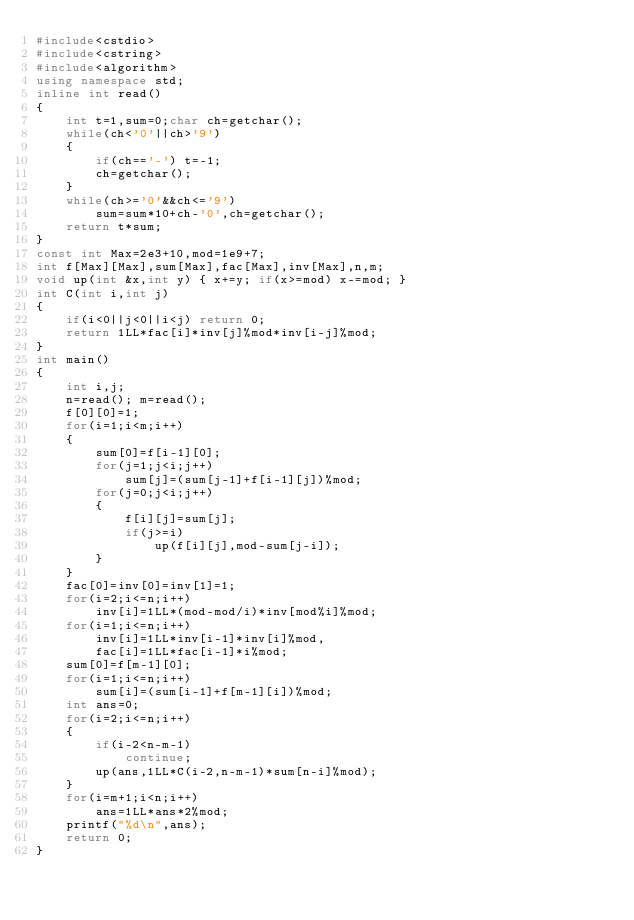<code> <loc_0><loc_0><loc_500><loc_500><_C++_>#include<cstdio>
#include<cstring>
#include<algorithm>
using namespace std;
inline int read()
{
	int t=1,sum=0;char ch=getchar();
	while(ch<'0'||ch>'9')
	{
		if(ch=='-') t=-1;
		ch=getchar();
	}
	while(ch>='0'&&ch<='9')
		sum=sum*10+ch-'0',ch=getchar();
	return t*sum;
}
const int Max=2e3+10,mod=1e9+7;
int f[Max][Max],sum[Max],fac[Max],inv[Max],n,m;
void up(int &x,int y) { x+=y; if(x>=mod) x-=mod; }
int C(int i,int j) 
{ 
	if(i<0||j<0||i<j) return 0;
	return 1LL*fac[i]*inv[j]%mod*inv[i-j]%mod; 
}
int main()
{
	int i,j;
	n=read(); m=read();
	f[0][0]=1;
	for(i=1;i<m;i++)
	{
		sum[0]=f[i-1][0];
		for(j=1;j<i;j++)
			sum[j]=(sum[j-1]+f[i-1][j])%mod;
		for(j=0;j<i;j++)
		{
			f[i][j]=sum[j];
			if(j>=i)
				up(f[i][j],mod-sum[j-i]);
		}
	}
	fac[0]=inv[0]=inv[1]=1;
	for(i=2;i<=n;i++)
		inv[i]=1LL*(mod-mod/i)*inv[mod%i]%mod;
	for(i=1;i<=n;i++)
		inv[i]=1LL*inv[i-1]*inv[i]%mod,
		fac[i]=1LL*fac[i-1]*i%mod;
	sum[0]=f[m-1][0];
	for(i=1;i<=n;i++)
		sum[i]=(sum[i-1]+f[m-1][i])%mod;
	int ans=0;
	for(i=2;i<=n;i++)
	{
		if(i-2<n-m-1)
			continue;
		up(ans,1LL*C(i-2,n-m-1)*sum[n-i]%mod);
	}
	for(i=m+1;i<n;i++)
		ans=1LL*ans*2%mod;
	printf("%d\n",ans);
	return 0;
}</code> 